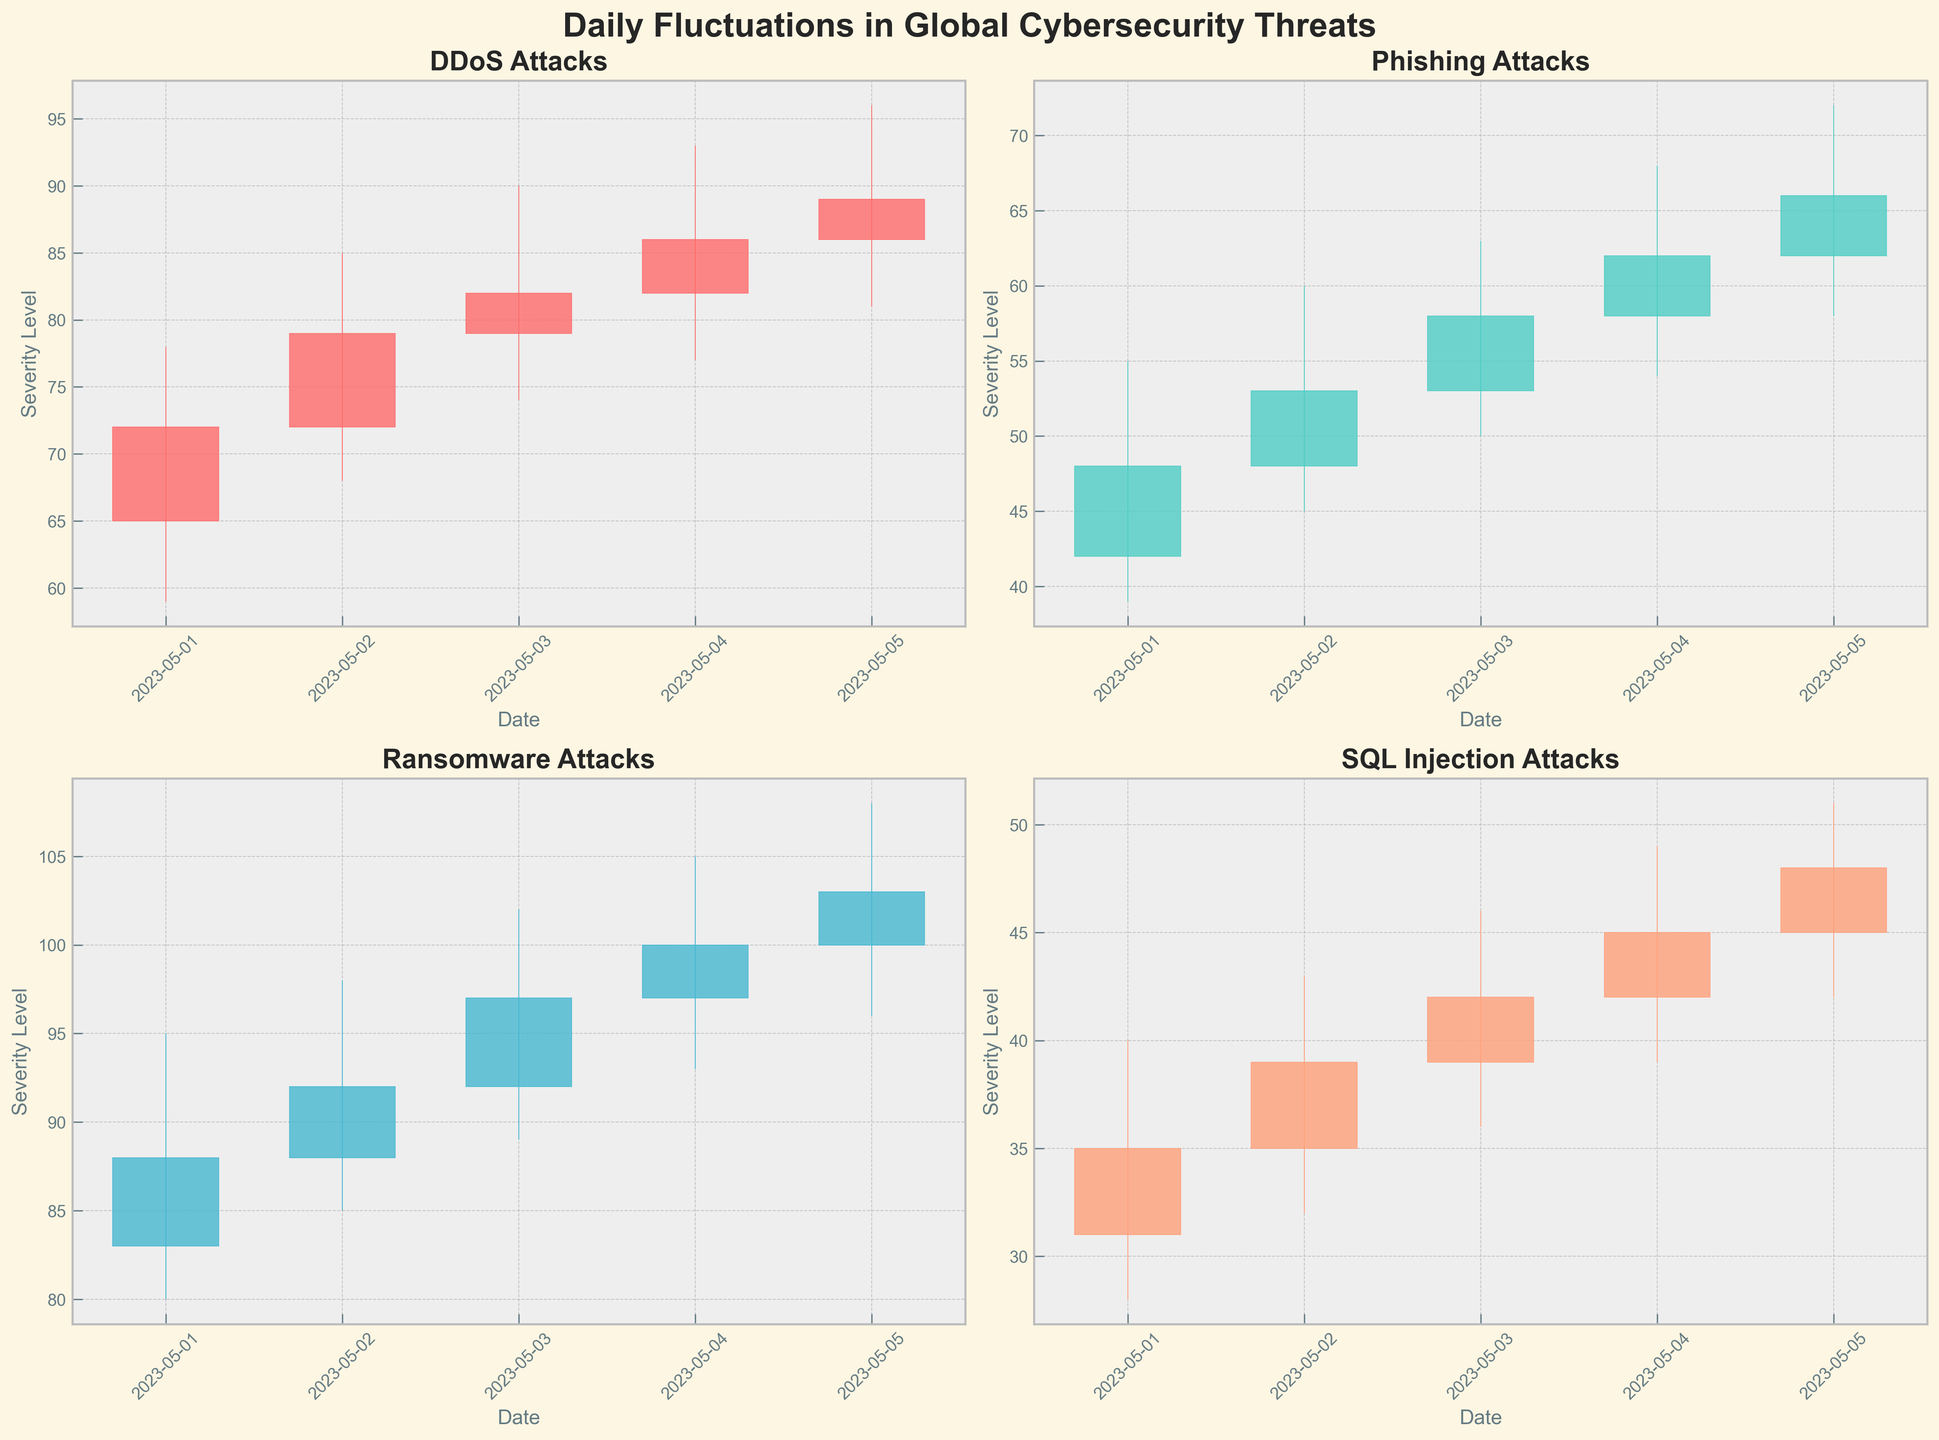What is the title of the figure? The title of the figure is displayed at the very top and reads "Daily Fluctuations in Global Cybersecurity Threats."
Answer: Daily Fluctuations in Global Cybersecurity Threats Which attack type experienced the highest severity level on any given day? By observing the "High" values in the OHLC charts for all attack types, the Ransomware attack on 2023-05-05 had the highest severity level of 108.
Answer: Ransomware How many days are displayed in this figure for each attack type? Each attack type has 5 data points, corresponding to each day from 2023-05-01 to 2023-05-05.
Answer: 5 For DDoS attacks, what is the difference between the highest and lowest severity levels observed on 2023-05-03? For DDoS attacks on 2023-05-03, the highest severity level is 90 and the lowest is 74. The difference is calculated as 90 - 74 = 16.
Answer: 16 Which attack type shows the smallest range of severity levels on 2023-05-01? A range of severity levels can be assessed by subtracting the "Low" value from the "High" value. For 2023-05-01, the ranges for each attack type are: DDoS (78-59=19), Phishing (55-39=16), Ransomware (95-80=15), SQL Injection (40-28=12). The smallest range belongs to SQL Injection with a span of 12.
Answer: SQL Injection On which date did the Phishing attacks have their highest "High" value? By examining the OHLC chart for Phishing attacks, the highest "High" value for Phishing is 72 on 2023-05-05.
Answer: 2023-05-05 Which attack type shows an upward trend (closing values increasing) over the five days? An upward trend is observed when the closing values increase over time. Observing each plot, we see that SQL Injection attack types have closing values which increase from 35 on 2023-05-01 to 48 on 2023-05-05.
Answer: SQL Injection What was the closing severity level for Ransomware attacks on 2023-05-02? The closing severity level for Ransomware attacks on 2023-05-02 can be directly observed in the respective OHLC chart and is shown as 92.
Answer: 92 Which attack type exhibited the most significant increase in the closing severity level between two consecutive days? By reviewing the closing values between each consecutive day for all attack types, DDoS attacks showed an increase from 72 on 2023-05-01 to 79 on 2023-05-02, which is an increase of 7. Phishing and Ransomware have smaller increases, and SQL Injection's most significant increase is 4.
Answer: DDoS 